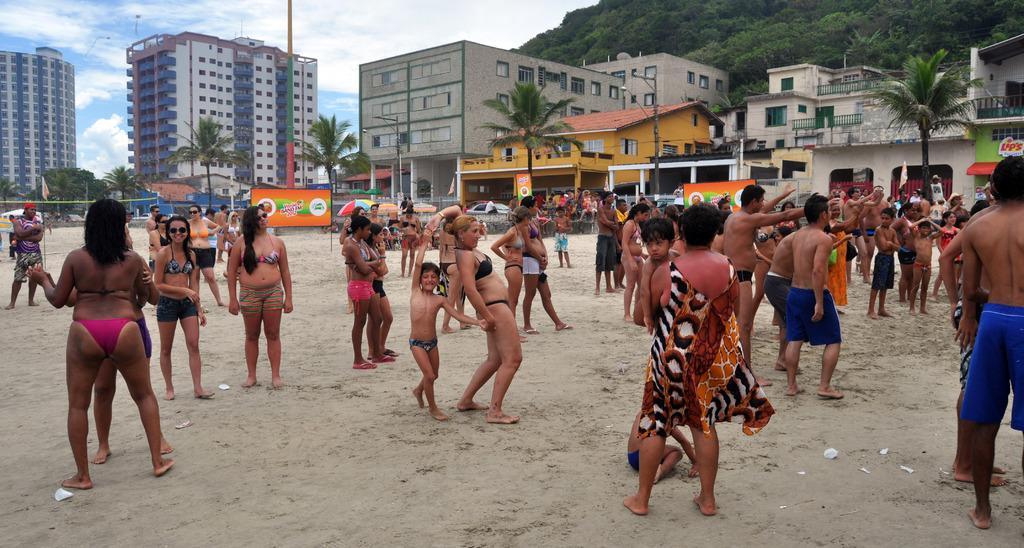In one or two sentences, can you explain what this image depicts? In this picture we can see a group of people on the ground and in the background we can see buildings, trees, boards, sky and some objects. 